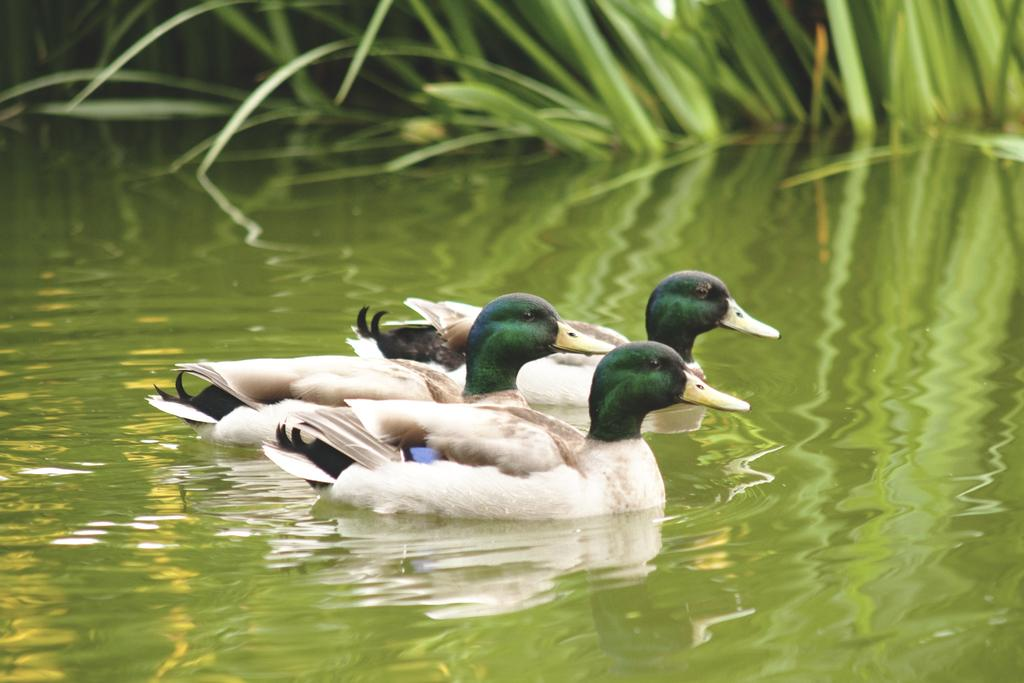How many ducks are in the image? There are three ducks in the image. Where are the ducks located? The ducks are present in the water. What can be seen in the background of the image? There is grass visible in the background of the image. What type of boundary can be seen in the image? There is no boundary present in the image; it features three ducks in the water with grass visible in the background. 